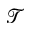Convert formula to latex. <formula><loc_0><loc_0><loc_500><loc_500>\mathcal { T }</formula> 